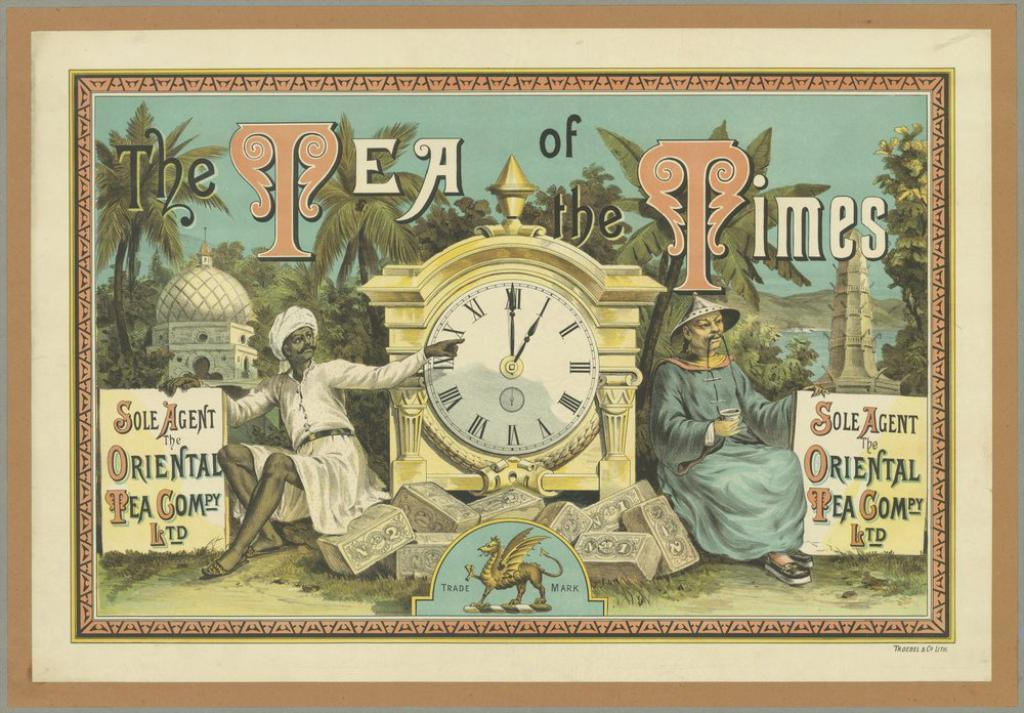<image>
Render a clear and concise summary of the photo. A framed picture is titled The Tea of Times. 